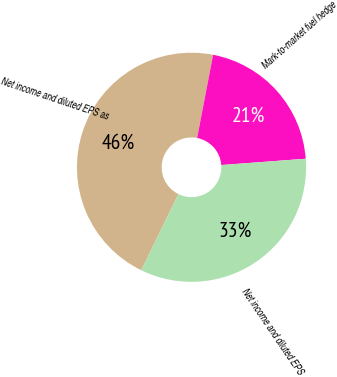<chart> <loc_0><loc_0><loc_500><loc_500><pie_chart><fcel>Net income and diluted EPS as<fcel>Mark-to-market fuel hedge<fcel>Net income and diluted EPS<nl><fcel>45.8%<fcel>20.79%<fcel>33.41%<nl></chart> 